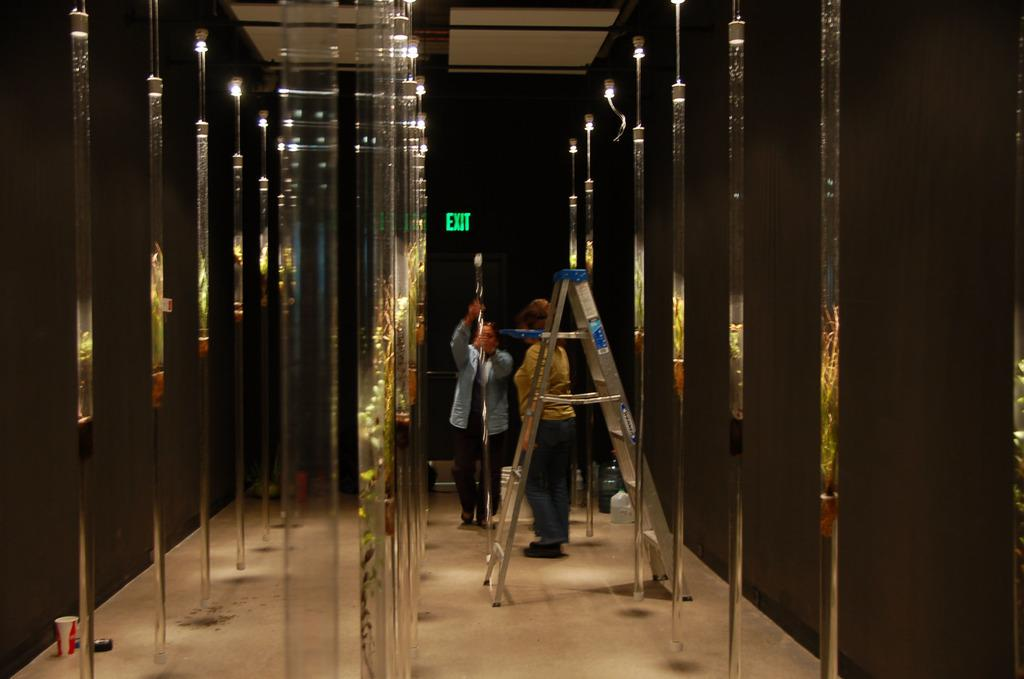Provide a one-sentence caption for the provided image. Green exit sign behind a man and woman. 